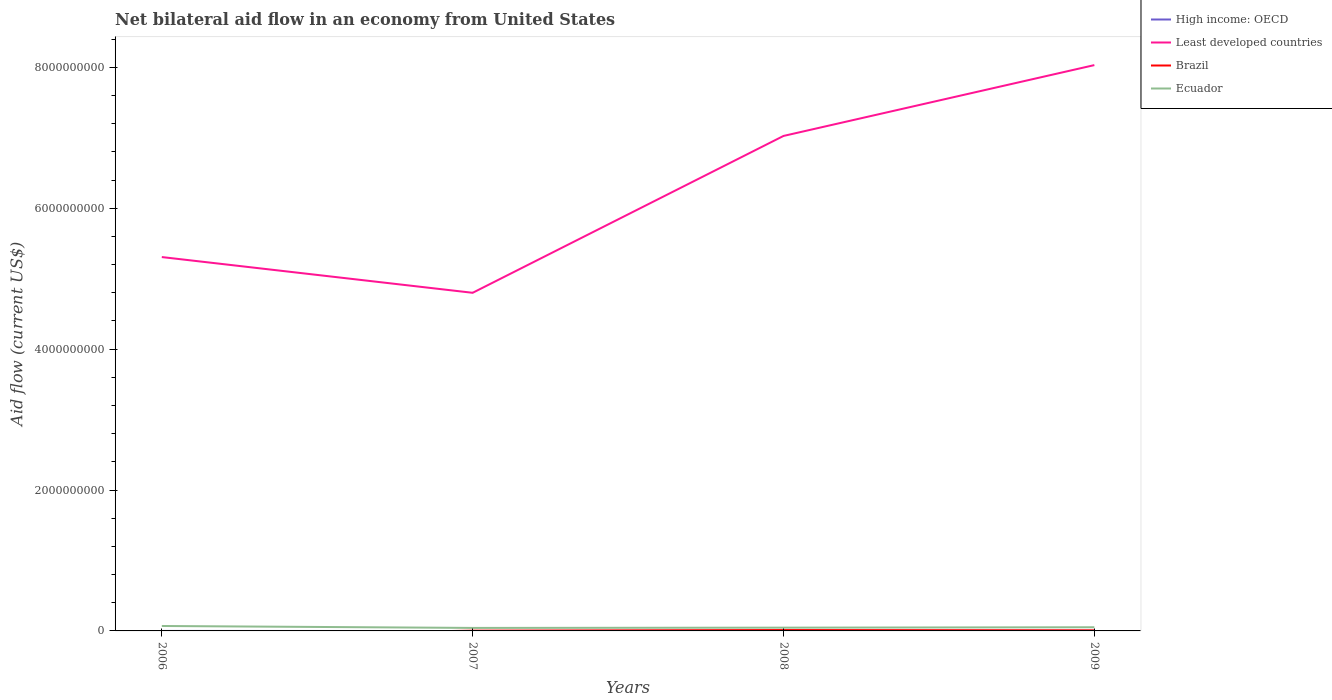Is the number of lines equal to the number of legend labels?
Provide a succinct answer. No. Across all years, what is the maximum net bilateral aid flow in Least developed countries?
Give a very brief answer. 4.80e+09. What is the total net bilateral aid flow in High income: OECD in the graph?
Keep it short and to the point. -8.90e+05. What is the difference between the highest and the second highest net bilateral aid flow in Least developed countries?
Provide a short and direct response. 3.23e+09. How many lines are there?
Your answer should be very brief. 4. Are the values on the major ticks of Y-axis written in scientific E-notation?
Make the answer very short. No. Does the graph contain grids?
Keep it short and to the point. No. Where does the legend appear in the graph?
Give a very brief answer. Top right. How are the legend labels stacked?
Keep it short and to the point. Vertical. What is the title of the graph?
Give a very brief answer. Net bilateral aid flow in an economy from United States. What is the label or title of the X-axis?
Your response must be concise. Years. What is the Aid flow (current US$) in High income: OECD in 2006?
Keep it short and to the point. 0. What is the Aid flow (current US$) of Least developed countries in 2006?
Make the answer very short. 5.31e+09. What is the Aid flow (current US$) of Brazil in 2006?
Ensure brevity in your answer.  0. What is the Aid flow (current US$) in Ecuador in 2006?
Ensure brevity in your answer.  7.01e+07. What is the Aid flow (current US$) in Least developed countries in 2007?
Offer a terse response. 4.80e+09. What is the Aid flow (current US$) of Brazil in 2007?
Provide a short and direct response. 3.85e+06. What is the Aid flow (current US$) of Ecuador in 2007?
Offer a terse response. 4.27e+07. What is the Aid flow (current US$) in High income: OECD in 2008?
Your answer should be very brief. 9.50e+05. What is the Aid flow (current US$) in Least developed countries in 2008?
Make the answer very short. 7.03e+09. What is the Aid flow (current US$) in Brazil in 2008?
Offer a terse response. 1.23e+07. What is the Aid flow (current US$) in Ecuador in 2008?
Your answer should be very brief. 4.64e+07. What is the Aid flow (current US$) of High income: OECD in 2009?
Your answer should be compact. 1.84e+06. What is the Aid flow (current US$) in Least developed countries in 2009?
Give a very brief answer. 8.03e+09. What is the Aid flow (current US$) in Brazil in 2009?
Offer a terse response. 8.14e+06. What is the Aid flow (current US$) in Ecuador in 2009?
Your answer should be very brief. 5.21e+07. Across all years, what is the maximum Aid flow (current US$) in High income: OECD?
Offer a terse response. 1.84e+06. Across all years, what is the maximum Aid flow (current US$) of Least developed countries?
Provide a succinct answer. 8.03e+09. Across all years, what is the maximum Aid flow (current US$) in Brazil?
Give a very brief answer. 1.23e+07. Across all years, what is the maximum Aid flow (current US$) of Ecuador?
Your answer should be compact. 7.01e+07. Across all years, what is the minimum Aid flow (current US$) of Least developed countries?
Your answer should be very brief. 4.80e+09. Across all years, what is the minimum Aid flow (current US$) in Ecuador?
Provide a short and direct response. 4.27e+07. What is the total Aid flow (current US$) in High income: OECD in the graph?
Keep it short and to the point. 2.79e+06. What is the total Aid flow (current US$) in Least developed countries in the graph?
Keep it short and to the point. 2.52e+1. What is the total Aid flow (current US$) of Brazil in the graph?
Provide a short and direct response. 2.43e+07. What is the total Aid flow (current US$) in Ecuador in the graph?
Give a very brief answer. 2.11e+08. What is the difference between the Aid flow (current US$) of Least developed countries in 2006 and that in 2007?
Ensure brevity in your answer.  5.07e+08. What is the difference between the Aid flow (current US$) in Ecuador in 2006 and that in 2007?
Give a very brief answer. 2.75e+07. What is the difference between the Aid flow (current US$) of Least developed countries in 2006 and that in 2008?
Your answer should be very brief. -1.72e+09. What is the difference between the Aid flow (current US$) in Ecuador in 2006 and that in 2008?
Provide a short and direct response. 2.38e+07. What is the difference between the Aid flow (current US$) of Least developed countries in 2006 and that in 2009?
Offer a terse response. -2.72e+09. What is the difference between the Aid flow (current US$) of Ecuador in 2006 and that in 2009?
Ensure brevity in your answer.  1.81e+07. What is the difference between the Aid flow (current US$) of Least developed countries in 2007 and that in 2008?
Offer a very short reply. -2.23e+09. What is the difference between the Aid flow (current US$) in Brazil in 2007 and that in 2008?
Offer a terse response. -8.48e+06. What is the difference between the Aid flow (current US$) in Ecuador in 2007 and that in 2008?
Provide a short and direct response. -3.70e+06. What is the difference between the Aid flow (current US$) of Least developed countries in 2007 and that in 2009?
Keep it short and to the point. -3.23e+09. What is the difference between the Aid flow (current US$) in Brazil in 2007 and that in 2009?
Keep it short and to the point. -4.29e+06. What is the difference between the Aid flow (current US$) of Ecuador in 2007 and that in 2009?
Make the answer very short. -9.41e+06. What is the difference between the Aid flow (current US$) in High income: OECD in 2008 and that in 2009?
Provide a succinct answer. -8.90e+05. What is the difference between the Aid flow (current US$) of Least developed countries in 2008 and that in 2009?
Your answer should be compact. -1.01e+09. What is the difference between the Aid flow (current US$) in Brazil in 2008 and that in 2009?
Offer a very short reply. 4.19e+06. What is the difference between the Aid flow (current US$) in Ecuador in 2008 and that in 2009?
Ensure brevity in your answer.  -5.71e+06. What is the difference between the Aid flow (current US$) in Least developed countries in 2006 and the Aid flow (current US$) in Brazil in 2007?
Ensure brevity in your answer.  5.30e+09. What is the difference between the Aid flow (current US$) in Least developed countries in 2006 and the Aid flow (current US$) in Ecuador in 2007?
Your answer should be very brief. 5.26e+09. What is the difference between the Aid flow (current US$) of Least developed countries in 2006 and the Aid flow (current US$) of Brazil in 2008?
Provide a succinct answer. 5.29e+09. What is the difference between the Aid flow (current US$) of Least developed countries in 2006 and the Aid flow (current US$) of Ecuador in 2008?
Your response must be concise. 5.26e+09. What is the difference between the Aid flow (current US$) of Least developed countries in 2006 and the Aid flow (current US$) of Brazil in 2009?
Give a very brief answer. 5.30e+09. What is the difference between the Aid flow (current US$) in Least developed countries in 2006 and the Aid flow (current US$) in Ecuador in 2009?
Your answer should be compact. 5.25e+09. What is the difference between the Aid flow (current US$) of Least developed countries in 2007 and the Aid flow (current US$) of Brazil in 2008?
Make the answer very short. 4.79e+09. What is the difference between the Aid flow (current US$) of Least developed countries in 2007 and the Aid flow (current US$) of Ecuador in 2008?
Make the answer very short. 4.75e+09. What is the difference between the Aid flow (current US$) in Brazil in 2007 and the Aid flow (current US$) in Ecuador in 2008?
Your answer should be very brief. -4.25e+07. What is the difference between the Aid flow (current US$) in Least developed countries in 2007 and the Aid flow (current US$) in Brazil in 2009?
Your answer should be compact. 4.79e+09. What is the difference between the Aid flow (current US$) in Least developed countries in 2007 and the Aid flow (current US$) in Ecuador in 2009?
Make the answer very short. 4.75e+09. What is the difference between the Aid flow (current US$) in Brazil in 2007 and the Aid flow (current US$) in Ecuador in 2009?
Offer a terse response. -4.82e+07. What is the difference between the Aid flow (current US$) of High income: OECD in 2008 and the Aid flow (current US$) of Least developed countries in 2009?
Your answer should be very brief. -8.03e+09. What is the difference between the Aid flow (current US$) in High income: OECD in 2008 and the Aid flow (current US$) in Brazil in 2009?
Provide a succinct answer. -7.19e+06. What is the difference between the Aid flow (current US$) of High income: OECD in 2008 and the Aid flow (current US$) of Ecuador in 2009?
Make the answer very short. -5.11e+07. What is the difference between the Aid flow (current US$) in Least developed countries in 2008 and the Aid flow (current US$) in Brazil in 2009?
Your response must be concise. 7.02e+09. What is the difference between the Aid flow (current US$) in Least developed countries in 2008 and the Aid flow (current US$) in Ecuador in 2009?
Your answer should be compact. 6.97e+09. What is the difference between the Aid flow (current US$) of Brazil in 2008 and the Aid flow (current US$) of Ecuador in 2009?
Ensure brevity in your answer.  -3.97e+07. What is the average Aid flow (current US$) of High income: OECD per year?
Offer a very short reply. 6.98e+05. What is the average Aid flow (current US$) in Least developed countries per year?
Provide a short and direct response. 6.29e+09. What is the average Aid flow (current US$) in Brazil per year?
Give a very brief answer. 6.08e+06. What is the average Aid flow (current US$) of Ecuador per year?
Offer a very short reply. 5.28e+07. In the year 2006, what is the difference between the Aid flow (current US$) in Least developed countries and Aid flow (current US$) in Ecuador?
Your answer should be compact. 5.24e+09. In the year 2007, what is the difference between the Aid flow (current US$) in Least developed countries and Aid flow (current US$) in Brazil?
Offer a very short reply. 4.80e+09. In the year 2007, what is the difference between the Aid flow (current US$) in Least developed countries and Aid flow (current US$) in Ecuador?
Make the answer very short. 4.76e+09. In the year 2007, what is the difference between the Aid flow (current US$) in Brazil and Aid flow (current US$) in Ecuador?
Provide a short and direct response. -3.88e+07. In the year 2008, what is the difference between the Aid flow (current US$) of High income: OECD and Aid flow (current US$) of Least developed countries?
Provide a succinct answer. -7.03e+09. In the year 2008, what is the difference between the Aid flow (current US$) of High income: OECD and Aid flow (current US$) of Brazil?
Ensure brevity in your answer.  -1.14e+07. In the year 2008, what is the difference between the Aid flow (current US$) of High income: OECD and Aid flow (current US$) of Ecuador?
Your response must be concise. -4.54e+07. In the year 2008, what is the difference between the Aid flow (current US$) of Least developed countries and Aid flow (current US$) of Brazil?
Offer a very short reply. 7.01e+09. In the year 2008, what is the difference between the Aid flow (current US$) in Least developed countries and Aid flow (current US$) in Ecuador?
Your answer should be compact. 6.98e+09. In the year 2008, what is the difference between the Aid flow (current US$) in Brazil and Aid flow (current US$) in Ecuador?
Offer a very short reply. -3.40e+07. In the year 2009, what is the difference between the Aid flow (current US$) in High income: OECD and Aid flow (current US$) in Least developed countries?
Offer a very short reply. -8.03e+09. In the year 2009, what is the difference between the Aid flow (current US$) of High income: OECD and Aid flow (current US$) of Brazil?
Offer a terse response. -6.30e+06. In the year 2009, what is the difference between the Aid flow (current US$) in High income: OECD and Aid flow (current US$) in Ecuador?
Your response must be concise. -5.02e+07. In the year 2009, what is the difference between the Aid flow (current US$) in Least developed countries and Aid flow (current US$) in Brazil?
Your response must be concise. 8.02e+09. In the year 2009, what is the difference between the Aid flow (current US$) of Least developed countries and Aid flow (current US$) of Ecuador?
Provide a succinct answer. 7.98e+09. In the year 2009, what is the difference between the Aid flow (current US$) of Brazil and Aid flow (current US$) of Ecuador?
Offer a very short reply. -4.39e+07. What is the ratio of the Aid flow (current US$) in Least developed countries in 2006 to that in 2007?
Offer a very short reply. 1.11. What is the ratio of the Aid flow (current US$) in Ecuador in 2006 to that in 2007?
Your response must be concise. 1.64. What is the ratio of the Aid flow (current US$) in Least developed countries in 2006 to that in 2008?
Provide a succinct answer. 0.76. What is the ratio of the Aid flow (current US$) of Ecuador in 2006 to that in 2008?
Offer a terse response. 1.51. What is the ratio of the Aid flow (current US$) of Least developed countries in 2006 to that in 2009?
Your answer should be compact. 0.66. What is the ratio of the Aid flow (current US$) in Ecuador in 2006 to that in 2009?
Your response must be concise. 1.35. What is the ratio of the Aid flow (current US$) in Least developed countries in 2007 to that in 2008?
Your response must be concise. 0.68. What is the ratio of the Aid flow (current US$) of Brazil in 2007 to that in 2008?
Provide a succinct answer. 0.31. What is the ratio of the Aid flow (current US$) of Ecuador in 2007 to that in 2008?
Ensure brevity in your answer.  0.92. What is the ratio of the Aid flow (current US$) of Least developed countries in 2007 to that in 2009?
Give a very brief answer. 0.6. What is the ratio of the Aid flow (current US$) of Brazil in 2007 to that in 2009?
Keep it short and to the point. 0.47. What is the ratio of the Aid flow (current US$) of Ecuador in 2007 to that in 2009?
Offer a very short reply. 0.82. What is the ratio of the Aid flow (current US$) in High income: OECD in 2008 to that in 2009?
Offer a very short reply. 0.52. What is the ratio of the Aid flow (current US$) of Least developed countries in 2008 to that in 2009?
Keep it short and to the point. 0.87. What is the ratio of the Aid flow (current US$) of Brazil in 2008 to that in 2009?
Give a very brief answer. 1.51. What is the ratio of the Aid flow (current US$) in Ecuador in 2008 to that in 2009?
Make the answer very short. 0.89. What is the difference between the highest and the second highest Aid flow (current US$) of Least developed countries?
Your response must be concise. 1.01e+09. What is the difference between the highest and the second highest Aid flow (current US$) in Brazil?
Provide a succinct answer. 4.19e+06. What is the difference between the highest and the second highest Aid flow (current US$) in Ecuador?
Give a very brief answer. 1.81e+07. What is the difference between the highest and the lowest Aid flow (current US$) of High income: OECD?
Provide a succinct answer. 1.84e+06. What is the difference between the highest and the lowest Aid flow (current US$) of Least developed countries?
Keep it short and to the point. 3.23e+09. What is the difference between the highest and the lowest Aid flow (current US$) in Brazil?
Offer a terse response. 1.23e+07. What is the difference between the highest and the lowest Aid flow (current US$) in Ecuador?
Your answer should be compact. 2.75e+07. 